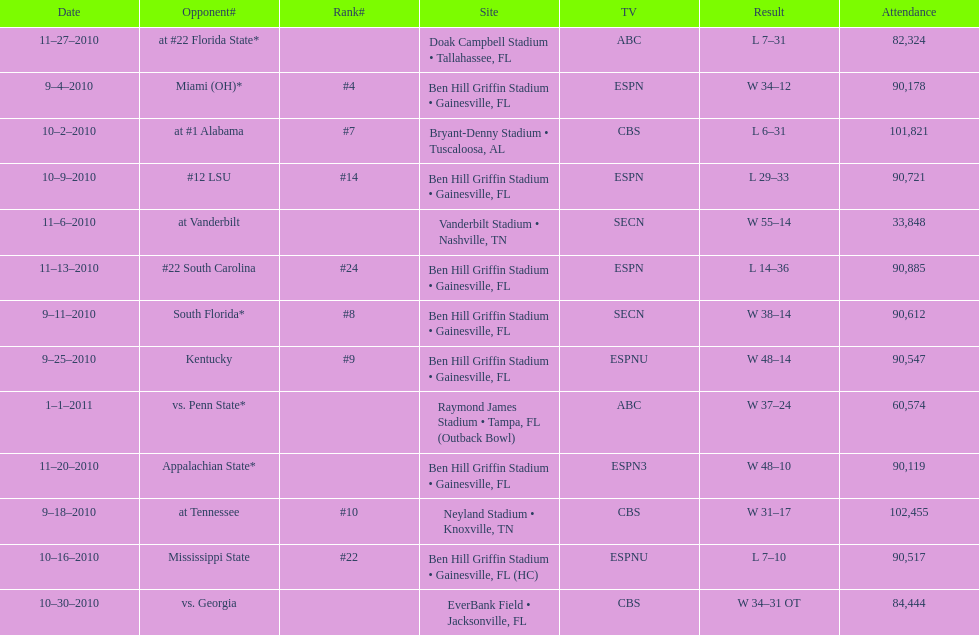How many games were played during the 2010-2011 season? 13. 